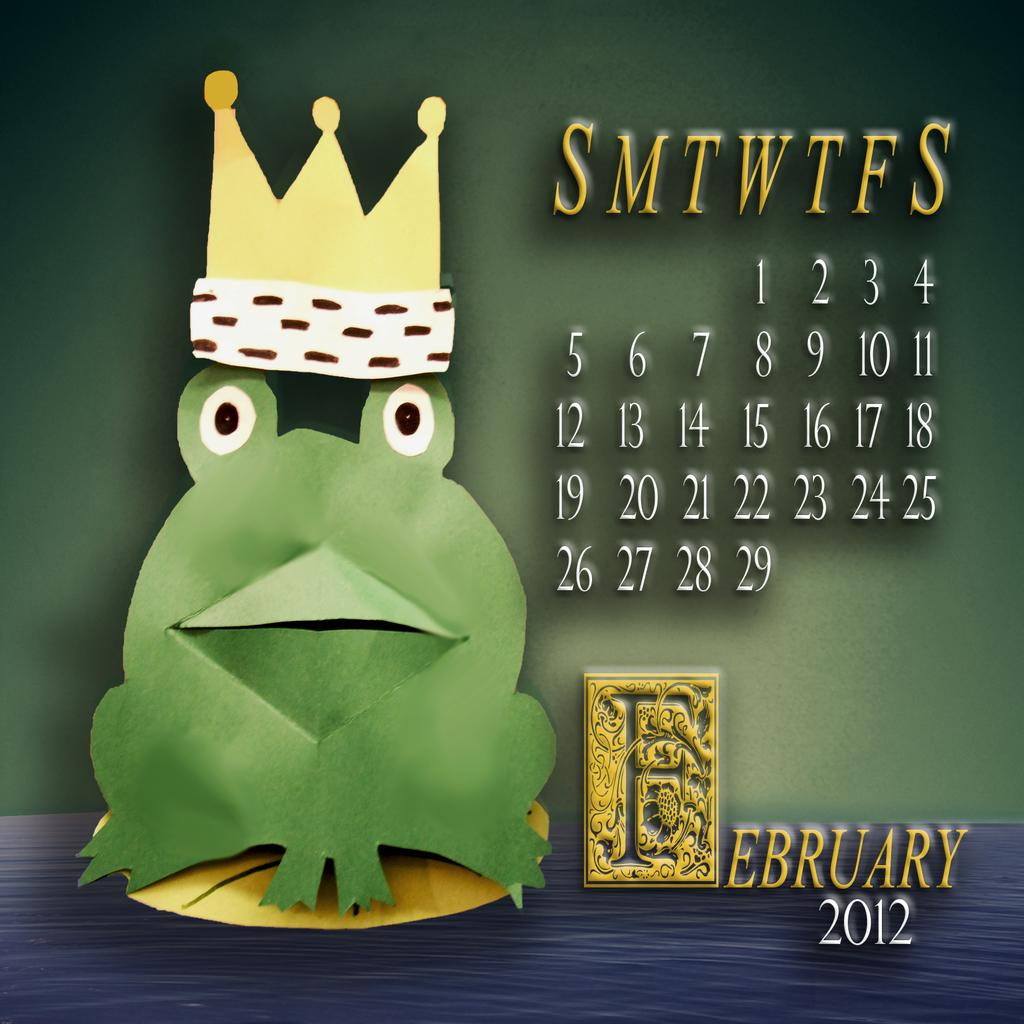What is the main object in the image? There is a calendar in the image. What additional element can be seen on the calendar? There is a cartoon image of a frog in the image. What other object is present in the image? There is a crown in the image. What type of nose can be seen on the frog in the image? There is no nose visible on the frog in the image, as it is a cartoon image and does not have a nose. 